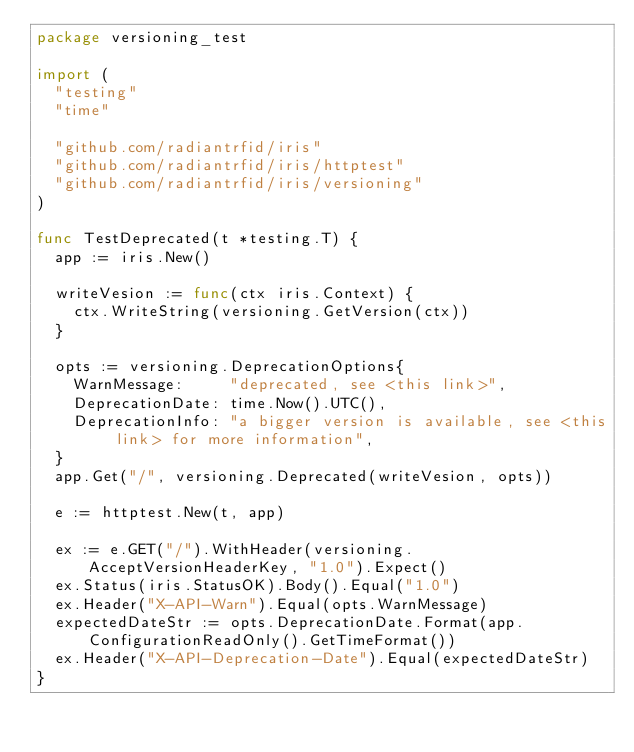Convert code to text. <code><loc_0><loc_0><loc_500><loc_500><_Go_>package versioning_test

import (
	"testing"
	"time"

	"github.com/radiantrfid/iris"
	"github.com/radiantrfid/iris/httptest"
	"github.com/radiantrfid/iris/versioning"
)

func TestDeprecated(t *testing.T) {
	app := iris.New()

	writeVesion := func(ctx iris.Context) {
		ctx.WriteString(versioning.GetVersion(ctx))
	}

	opts := versioning.DeprecationOptions{
		WarnMessage:     "deprecated, see <this link>",
		DeprecationDate: time.Now().UTC(),
		DeprecationInfo: "a bigger version is available, see <this link> for more information",
	}
	app.Get("/", versioning.Deprecated(writeVesion, opts))

	e := httptest.New(t, app)

	ex := e.GET("/").WithHeader(versioning.AcceptVersionHeaderKey, "1.0").Expect()
	ex.Status(iris.StatusOK).Body().Equal("1.0")
	ex.Header("X-API-Warn").Equal(opts.WarnMessage)
	expectedDateStr := opts.DeprecationDate.Format(app.ConfigurationReadOnly().GetTimeFormat())
	ex.Header("X-API-Deprecation-Date").Equal(expectedDateStr)
}
</code> 